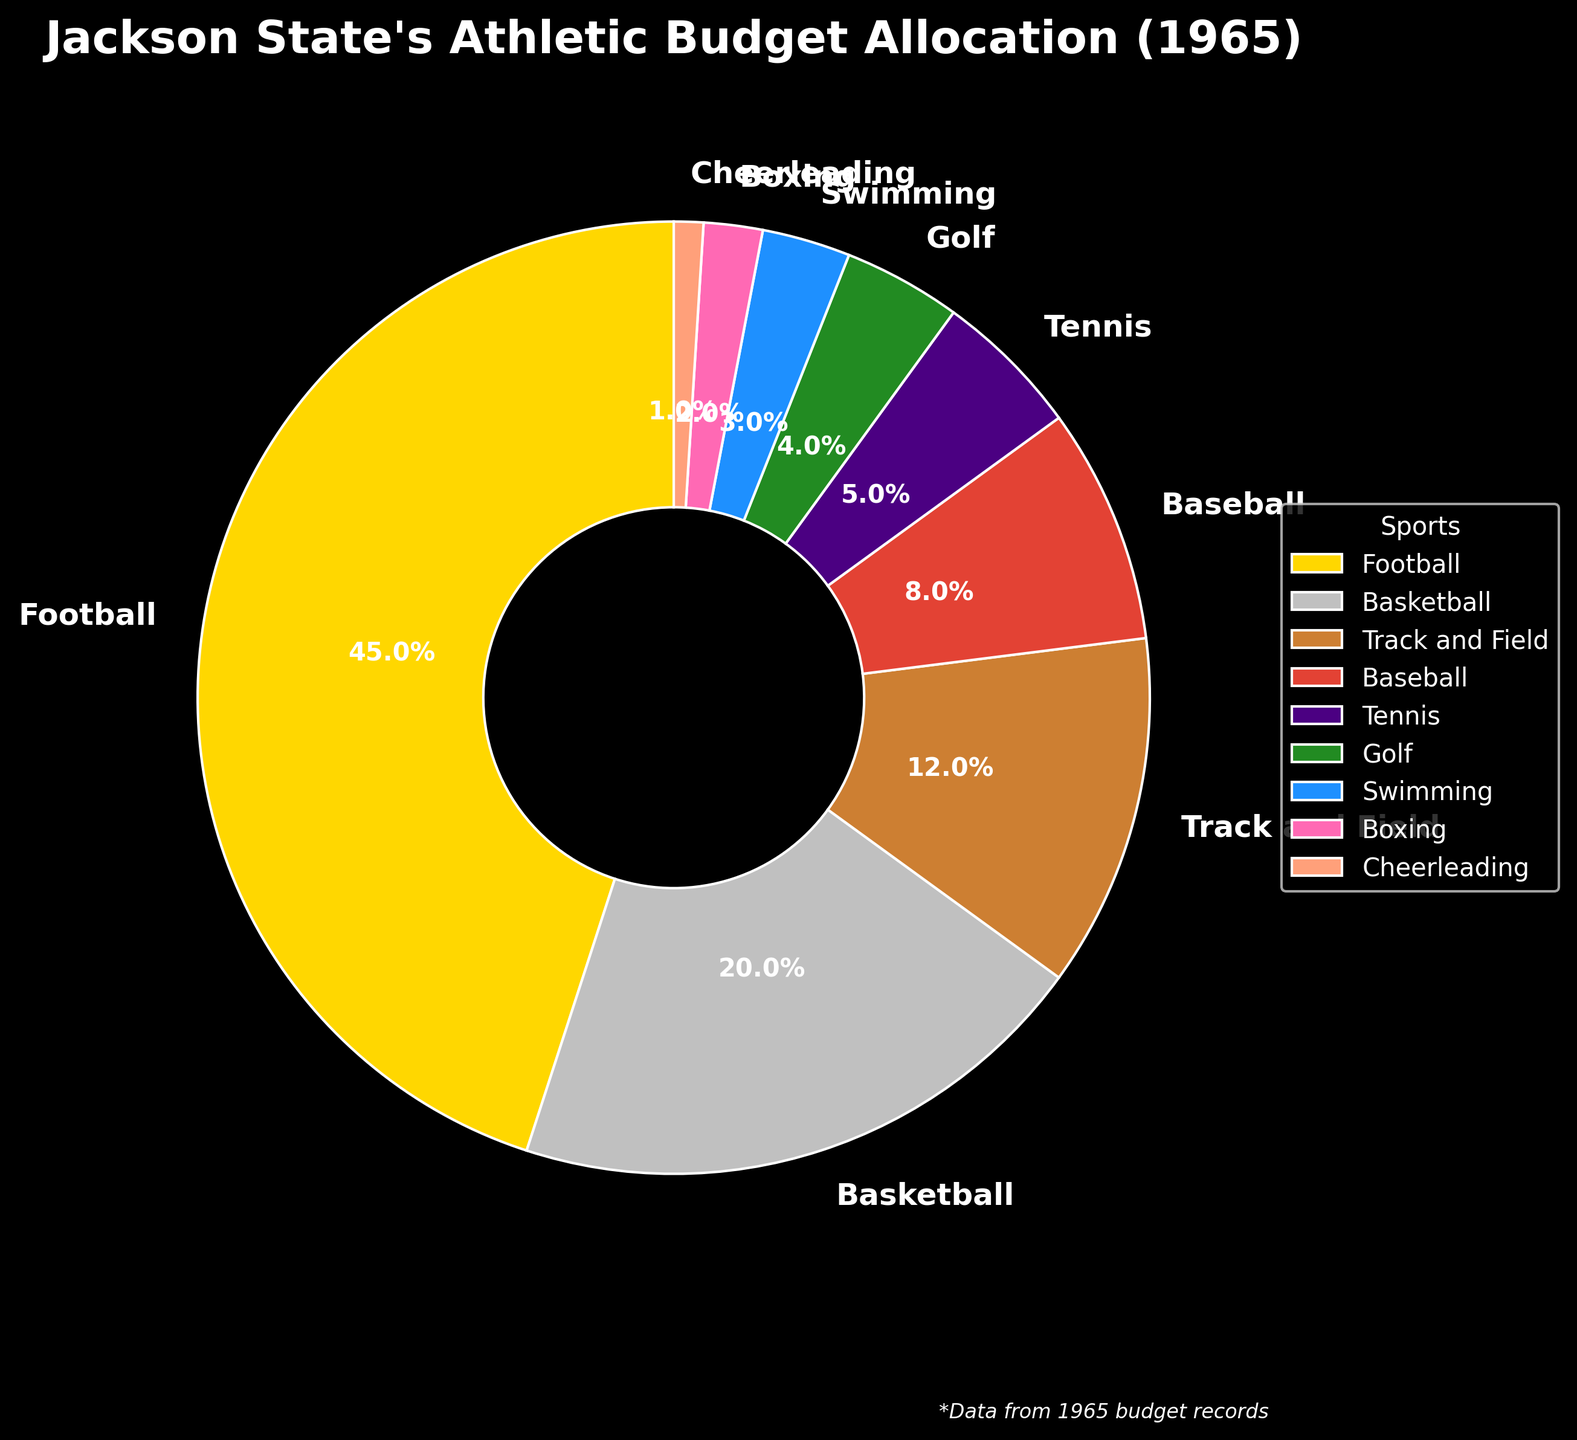How much more budget is allocated to Football compared to Baseball? Football has a 45% allocation and Baseball has 8%. The difference is 45% - 8% = 37%.
Answer: 37% Which sport gets the least amount of budget allocation? By checking the smallest percentage slice of the pie, Boxing has the smallest allocation with 2%.
Answer: Boxing How much budget allocation is given to both Basketball and Track and Field combined? Basketball has 20% and Track and Field has 12%, so their combined allocation is 20% + 12% = 32%.
Answer: 32% Is the budget allocation for Tennis greater than for Golf? Tennis has a 5% allocation while Golf has 4%. Therefore, Tennis has a greater allocation.
Answer: Yes What percentage of the budget is allocated to sports other than Football and Basketball? Football and Basketball combined have 45% + 20% = 65%. So, remaining sports have 100% - 65% = 35%.
Answer: 35% Are there any sports with the same budget allocation? By looking at the pie chart, no two sports have the same allocation percentages.
Answer: No What is the difference in budget allocation between Track and Field and Swimming? Track and Field has 12% while Swimming has 3%. The difference is 12% - 3% = 9%.
Answer: 9% Approximately what fraction of the budget does Tennis and Golf together take up compared to the total budget? Tennis has 5% and Golf has 4%, so combined they have 5% + 4% = 9%. Therefore, they take up 9/100 of the budget, which simplifies to about 9/100 or 0.09 of the total budget.
Answer: 0.09 How does the budget allocation for Cheerleading compare to Boxing? Cheerleading has a 1% allocation while Boxing has 2%, meaning Boxing has double the budget allocated compared to Cheerleading.
Answer: Boxing has double What sport receives twice the budget allocation of Swimming? Swimming has 3%. Tennis receives twice the budget of Swimming, which is 2 * 3% = 6%, and the closest to this is Tennis with 5%.
Answer: None 